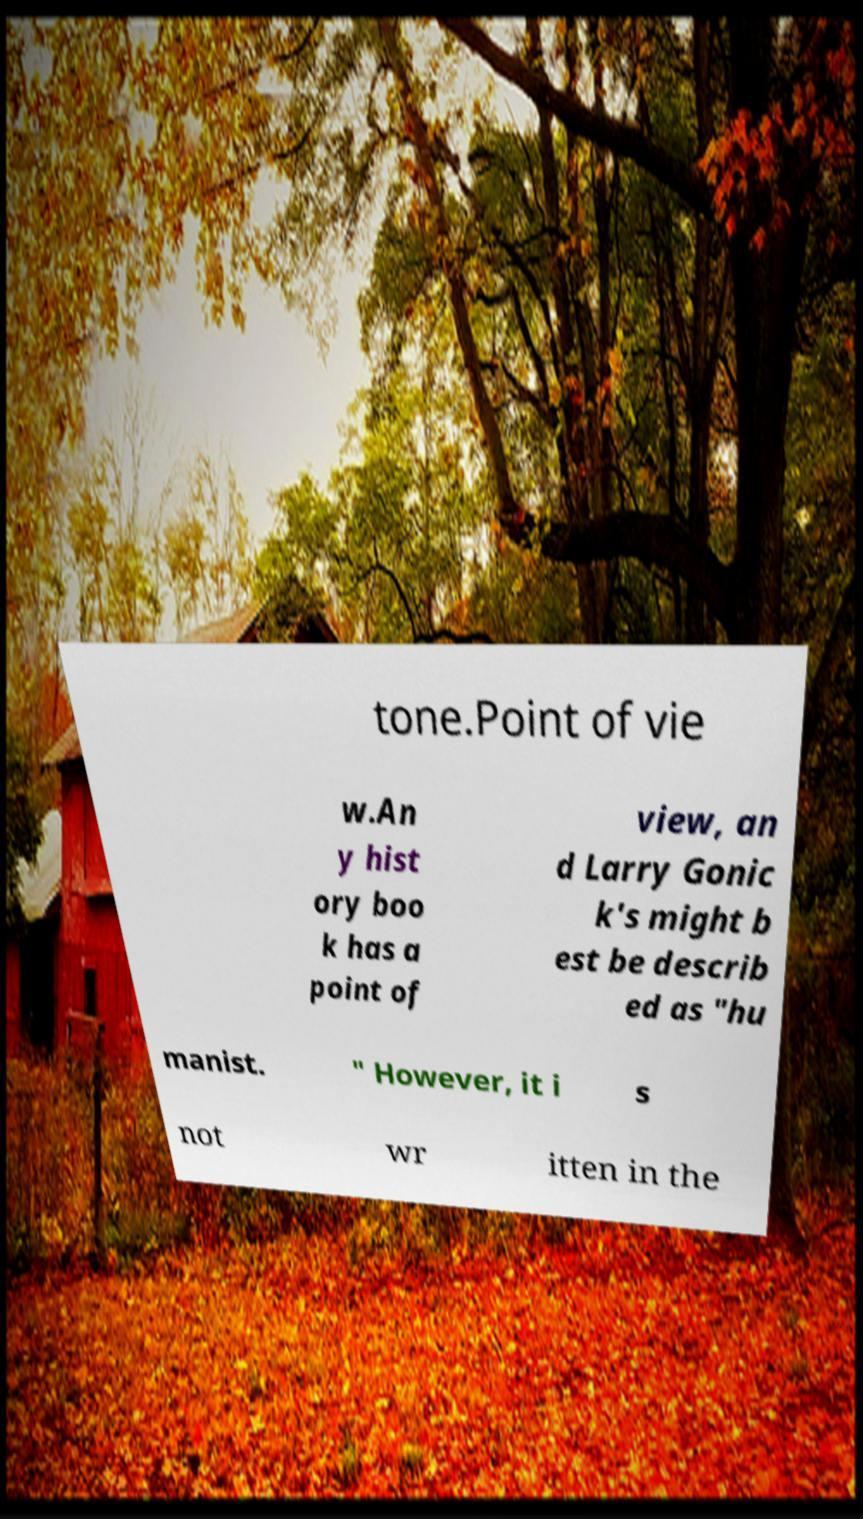Can you accurately transcribe the text from the provided image for me? tone.Point of vie w.An y hist ory boo k has a point of view, an d Larry Gonic k's might b est be describ ed as "hu manist. " However, it i s not wr itten in the 